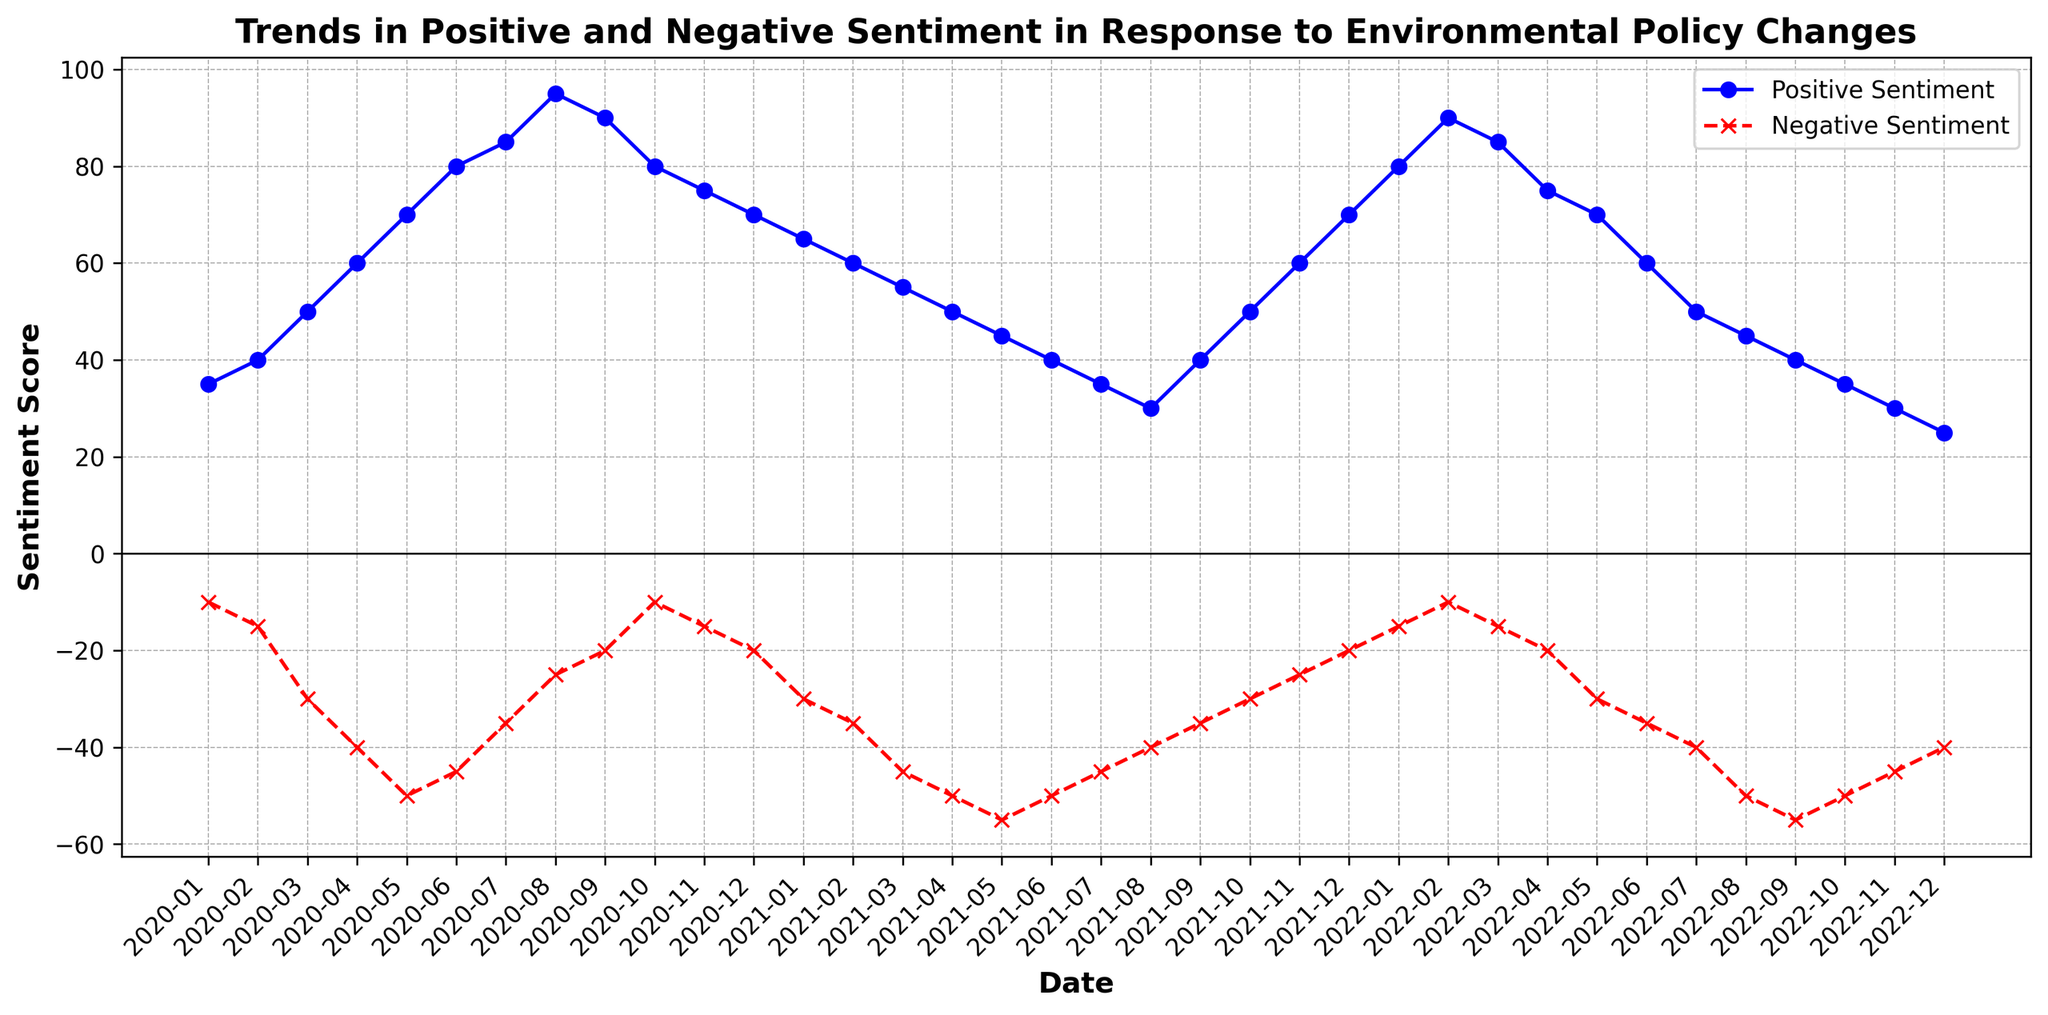What trend is observed in positive sentiment from January 2020 to August 2020? The positive sentiment shows an upward trend from January 2020 (35) to August 2020 (95), indicating increasing public approval of the environmental policy changes over these months.
Answer: Upward trend How does the negative sentiment in September 2020 compare to September 2021? In September 2020, the negative sentiment is -20, while in September 2021 it is -35. This indicates that in September 2021, the public's negative sentiment was higher compared to the same month in the previous year.
Answer: Higher in September 2021 Identify the month with the lowest positive sentiment in 2022 and provide its value. The lowest positive sentiment in 2022 occurs in December, with a value of 25.
Answer: December, 25 What is the range of positive sentiment values for the year 2020? The highest value of positive sentiment in 2020 is 95 (August), and the lowest is 35 (January). The range is calculated as the difference between these values: 95 - 35 = 60.
Answer: 60 Compare the highest negative sentiment in 2021 with the highest negative sentiment in 2022. The highest negative sentiment in 2021 is -55 in May, while the highest in 2022 is -55 in September. Both values are equal.
Answer: Both -55 What is the general trend in the negative sentiment from May 2020 to December 2020? From May 2020 (-50) to December 2020 (-20), the negative sentiment generally decreases (becomes less negative), indicating an improving public response in terms of reduced negativity.
Answer: Decreasing trend How does the positive sentiment trend change after reaching its peak in 2020? After peaking at 95 in August 2020, the positive sentiment experiences a decline, dropping to 40 by June 2021.
Answer: Declines Which month exhibits the highest positive sentiment throughout the entire dataset, and what is the corresponding negative sentiment for that month? August 2020 exhibits the highest positive sentiment with a value of 95. The corresponding negative sentiment for that month is -25.
Answer: August 2020; -25 Is there a month where both positive and negative sentiments are equal? No, there is no month in the dataset where positive and negative sentiments are equal. The graph shows that positive sentiment values are always positive and never equal to the negative sentiment values.
Answer: No 